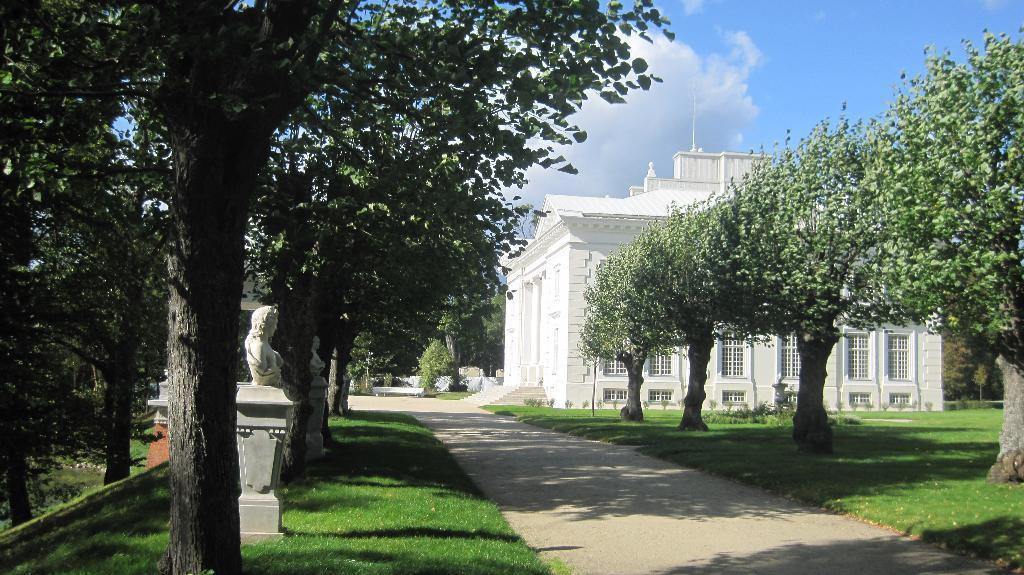What type of house is in the image? There is a white house in the image. What is around the house? The house is surrounded by green grass. What else can be seen in the image besides the house and grass? There are trees and a walking path in the image. What color is the sky in the image? The sky is blue in the image. How many flowers are in the image? There are no flowers mentioned or visible in the image. What type of surprise is happening in the image? There is no indication of a surprise in the image. 